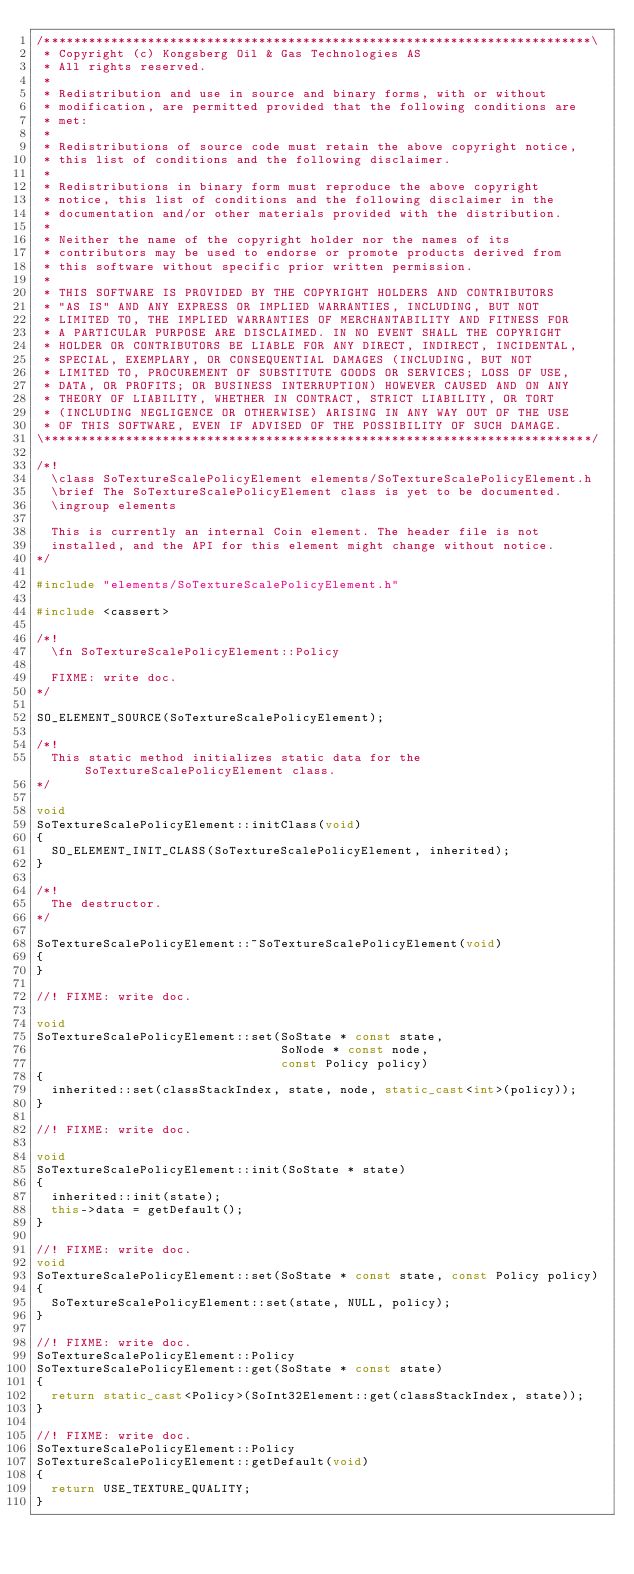<code> <loc_0><loc_0><loc_500><loc_500><_C++_>/**************************************************************************\
 * Copyright (c) Kongsberg Oil & Gas Technologies AS
 * All rights reserved.
 * 
 * Redistribution and use in source and binary forms, with or without
 * modification, are permitted provided that the following conditions are
 * met:
 * 
 * Redistributions of source code must retain the above copyright notice,
 * this list of conditions and the following disclaimer.
 * 
 * Redistributions in binary form must reproduce the above copyright
 * notice, this list of conditions and the following disclaimer in the
 * documentation and/or other materials provided with the distribution.
 * 
 * Neither the name of the copyright holder nor the names of its
 * contributors may be used to endorse or promote products derived from
 * this software without specific prior written permission.
 * 
 * THIS SOFTWARE IS PROVIDED BY THE COPYRIGHT HOLDERS AND CONTRIBUTORS
 * "AS IS" AND ANY EXPRESS OR IMPLIED WARRANTIES, INCLUDING, BUT NOT
 * LIMITED TO, THE IMPLIED WARRANTIES OF MERCHANTABILITY AND FITNESS FOR
 * A PARTICULAR PURPOSE ARE DISCLAIMED. IN NO EVENT SHALL THE COPYRIGHT
 * HOLDER OR CONTRIBUTORS BE LIABLE FOR ANY DIRECT, INDIRECT, INCIDENTAL,
 * SPECIAL, EXEMPLARY, OR CONSEQUENTIAL DAMAGES (INCLUDING, BUT NOT
 * LIMITED TO, PROCUREMENT OF SUBSTITUTE GOODS OR SERVICES; LOSS OF USE,
 * DATA, OR PROFITS; OR BUSINESS INTERRUPTION) HOWEVER CAUSED AND ON ANY
 * THEORY OF LIABILITY, WHETHER IN CONTRACT, STRICT LIABILITY, OR TORT
 * (INCLUDING NEGLIGENCE OR OTHERWISE) ARISING IN ANY WAY OUT OF THE USE
 * OF THIS SOFTWARE, EVEN IF ADVISED OF THE POSSIBILITY OF SUCH DAMAGE.
\**************************************************************************/

/*!
  \class SoTextureScalePolicyElement elements/SoTextureScalePolicyElement.h
  \brief The SoTextureScalePolicyElement class is yet to be documented.
  \ingroup elements

  This is currently an internal Coin element. The header file is not
  installed, and the API for this element might change without notice.
*/

#include "elements/SoTextureScalePolicyElement.h"

#include <cassert>

/*!
  \fn SoTextureScalePolicyElement::Policy

  FIXME: write doc.
*/

SO_ELEMENT_SOURCE(SoTextureScalePolicyElement);

/*!
  This static method initializes static data for the SoTextureScalePolicyElement class.
*/

void
SoTextureScalePolicyElement::initClass(void)
{
  SO_ELEMENT_INIT_CLASS(SoTextureScalePolicyElement, inherited);
}

/*!
  The destructor.
*/

SoTextureScalePolicyElement::~SoTextureScalePolicyElement(void)
{
}

//! FIXME: write doc.

void
SoTextureScalePolicyElement::set(SoState * const state,
                                 SoNode * const node,
                                 const Policy policy)
{
  inherited::set(classStackIndex, state, node, static_cast<int>(policy));
}

//! FIXME: write doc.

void
SoTextureScalePolicyElement::init(SoState * state)
{
  inherited::init(state);
  this->data = getDefault();
}

//! FIXME: write doc.
void
SoTextureScalePolicyElement::set(SoState * const state, const Policy policy)
{
  SoTextureScalePolicyElement::set(state, NULL, policy);
}

//! FIXME: write doc.
SoTextureScalePolicyElement::Policy
SoTextureScalePolicyElement::get(SoState * const state)
{
  return static_cast<Policy>(SoInt32Element::get(classStackIndex, state));
}

//! FIXME: write doc.
SoTextureScalePolicyElement::Policy
SoTextureScalePolicyElement::getDefault(void)
{
  return USE_TEXTURE_QUALITY;
}
</code> 